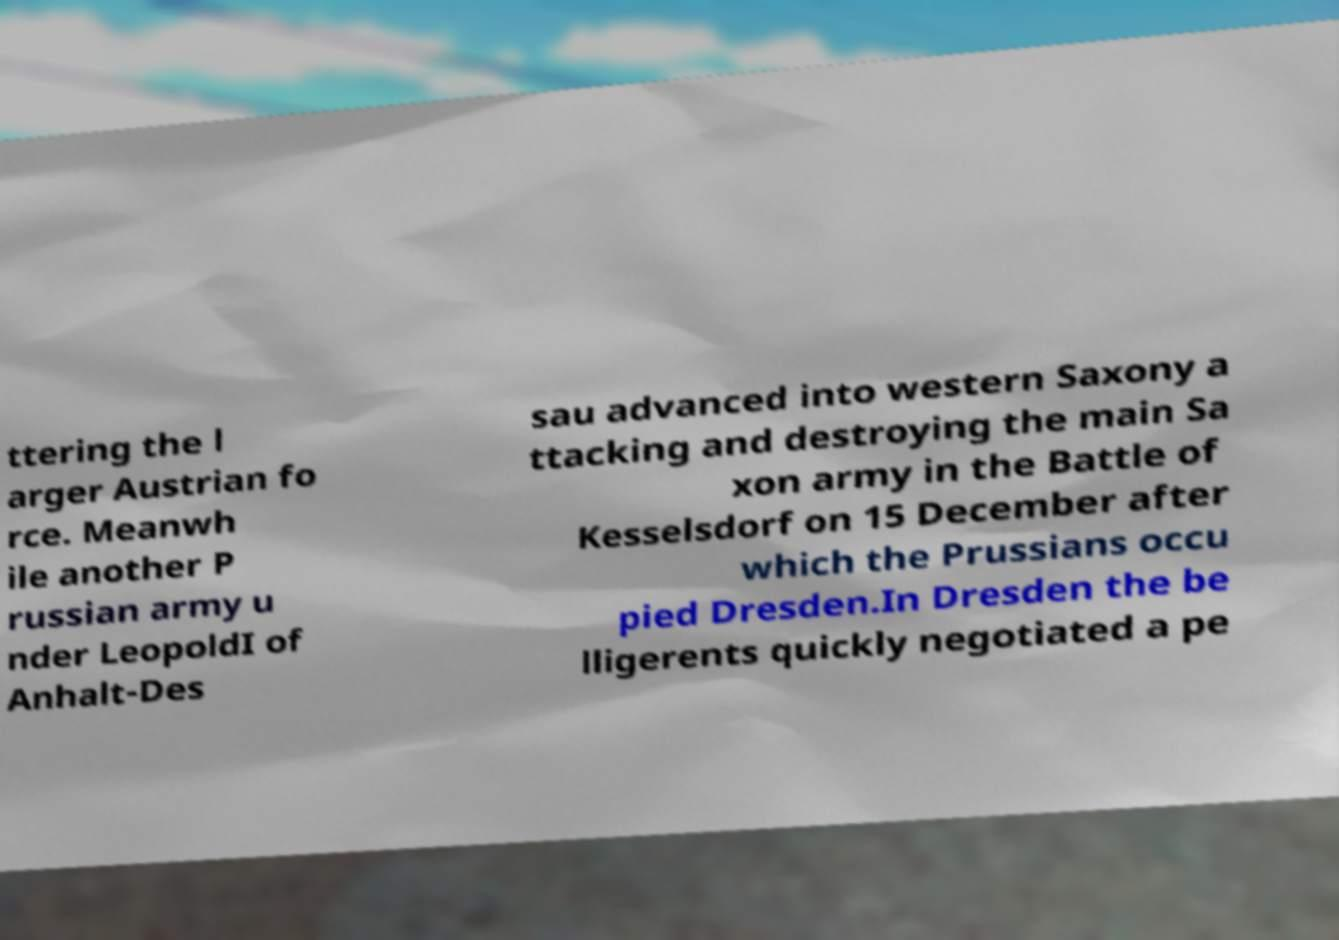There's text embedded in this image that I need extracted. Can you transcribe it verbatim? ttering the l arger Austrian fo rce. Meanwh ile another P russian army u nder LeopoldI of Anhalt-Des sau advanced into western Saxony a ttacking and destroying the main Sa xon army in the Battle of Kesselsdorf on 15 December after which the Prussians occu pied Dresden.In Dresden the be lligerents quickly negotiated a pe 